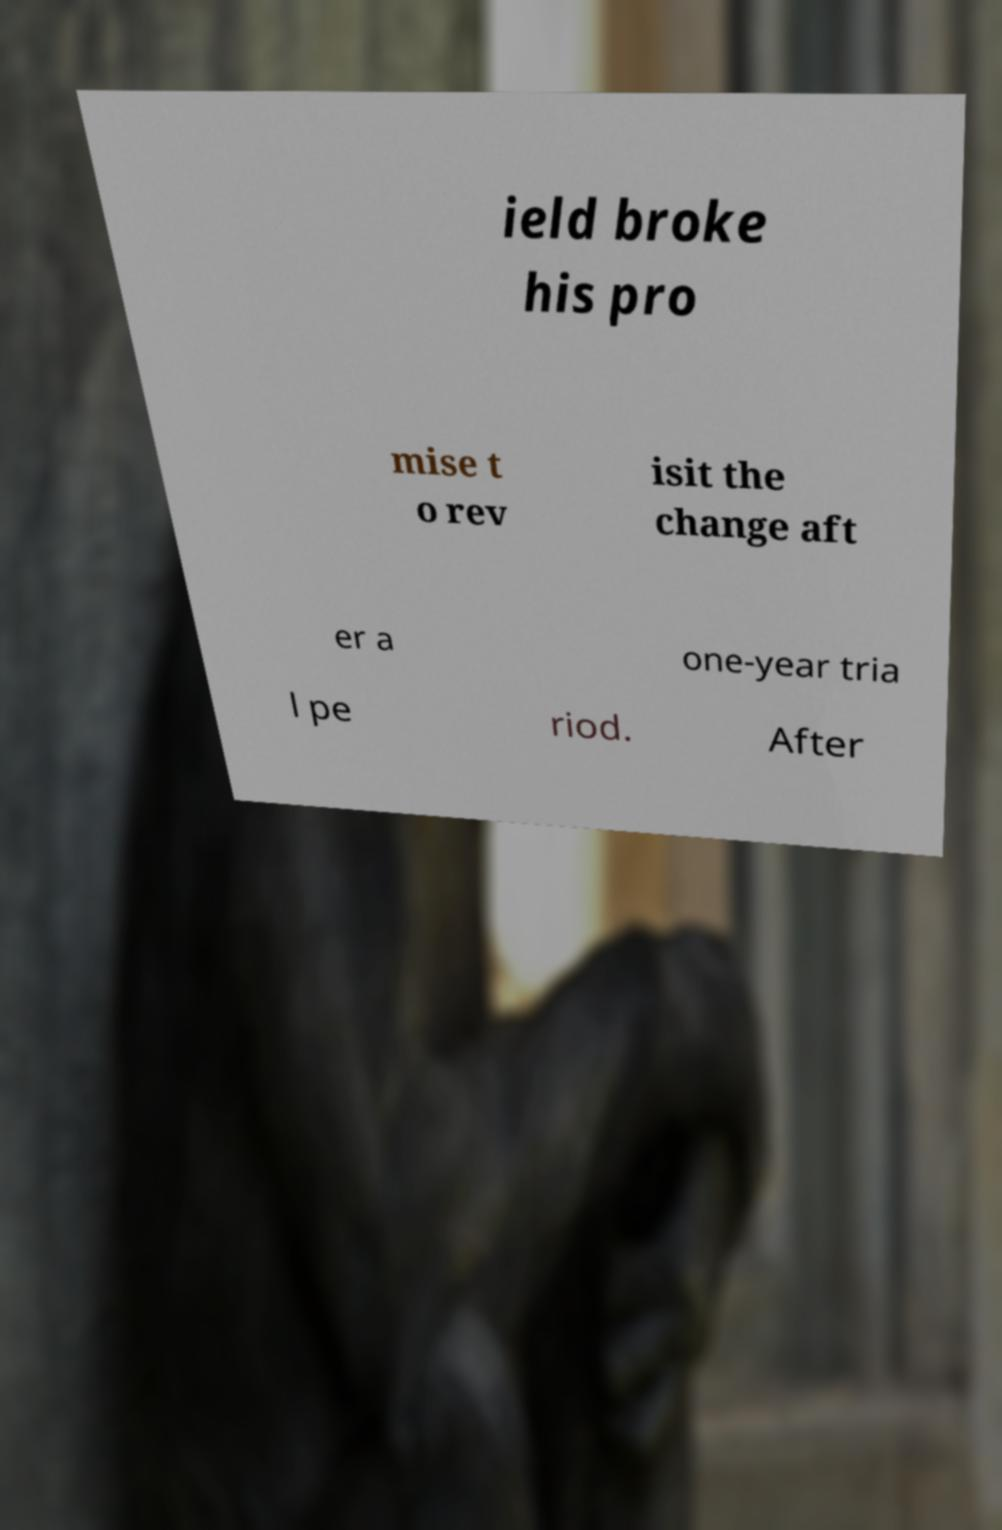For documentation purposes, I need the text within this image transcribed. Could you provide that? ield broke his pro mise t o rev isit the change aft er a one-year tria l pe riod. After 